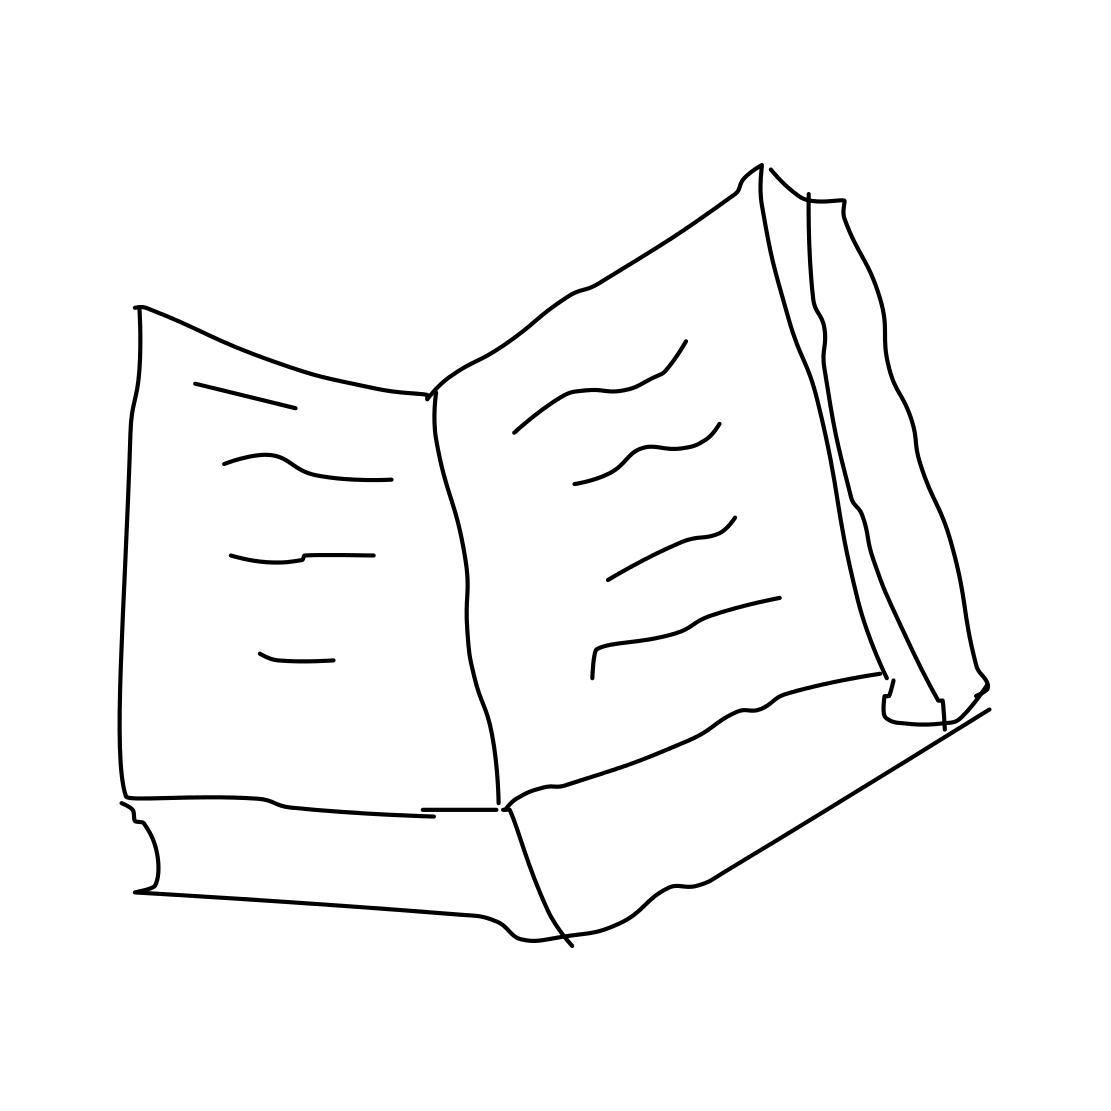What genre of book could this be? While the specific content isn't clear, the open book in the drawing could represent any genre, from fiction to nonfiction. The interpretation could depend on your imagination. 